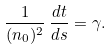<formula> <loc_0><loc_0><loc_500><loc_500>\frac { 1 } { ( n _ { 0 } ) ^ { 2 } } \, \frac { d t } { d s } = \gamma .</formula> 